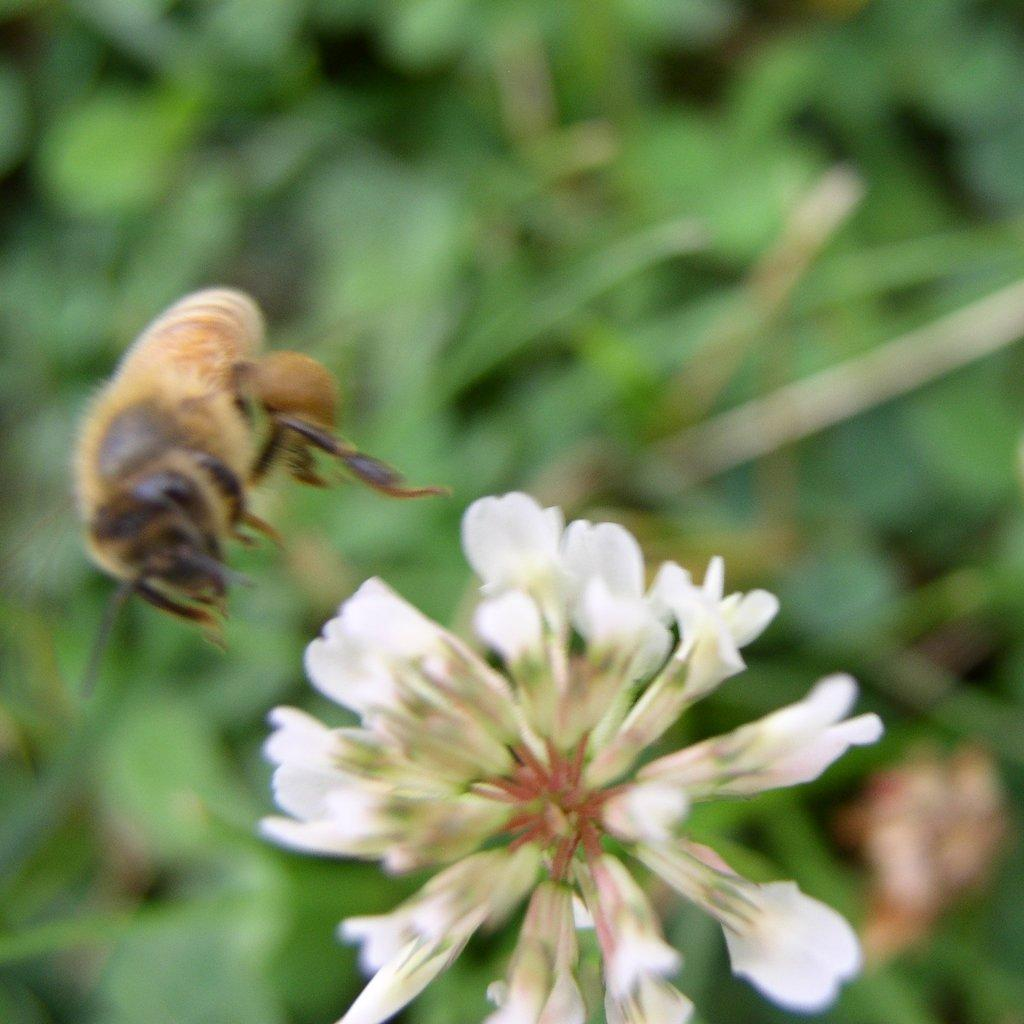What is flying in the air in the image? There is an insect flying in the air in the image. What type of flower can be seen in the image? There is a white color flower in the image. Can you describe the background of the image? The background of the image is blurred. What type of pail can be seen in the image? There is no pail present in the image. Is there a plane visible in the image? No, there is no plane visible in the image; only an insect flying in the air. 